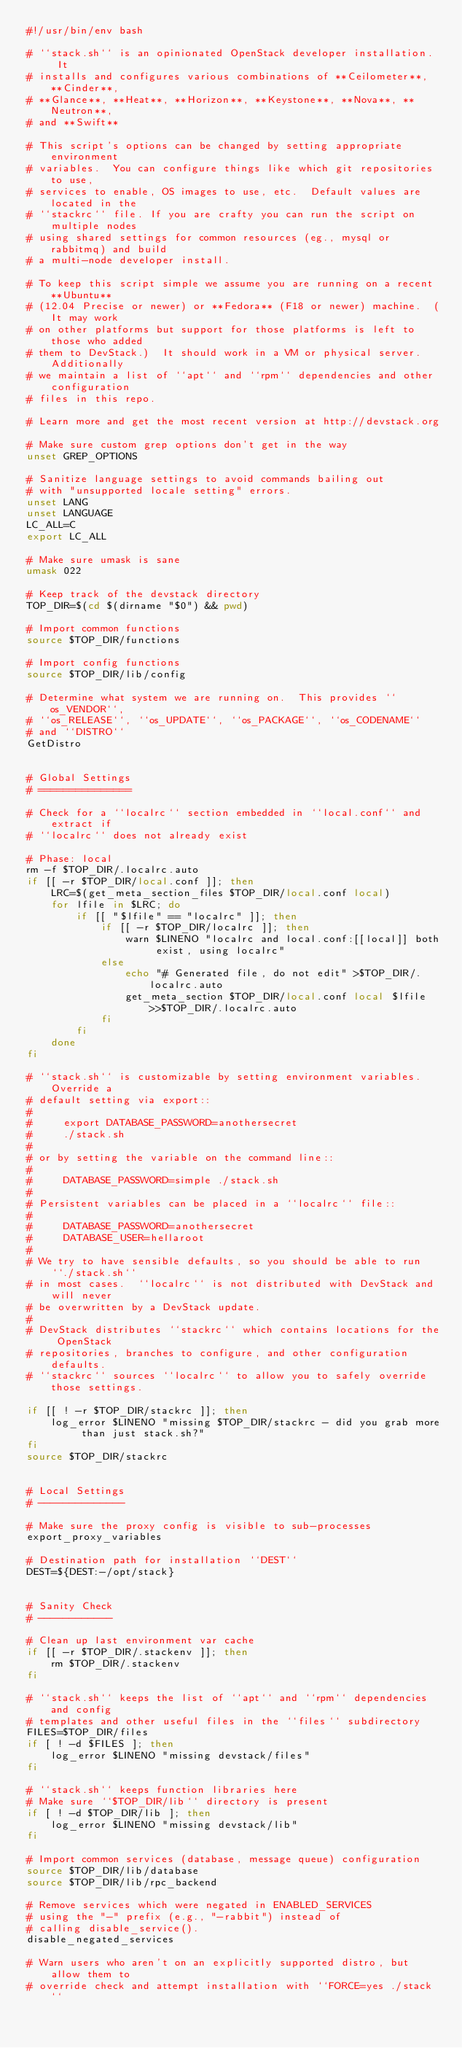<code> <loc_0><loc_0><loc_500><loc_500><_Bash_>#!/usr/bin/env bash

# ``stack.sh`` is an opinionated OpenStack developer installation.  It
# installs and configures various combinations of **Ceilometer**, **Cinder**,
# **Glance**, **Heat**, **Horizon**, **Keystone**, **Nova**, **Neutron**,
# and **Swift**

# This script's options can be changed by setting appropriate environment
# variables.  You can configure things like which git repositories to use,
# services to enable, OS images to use, etc.  Default values are located in the
# ``stackrc`` file. If you are crafty you can run the script on multiple nodes
# using shared settings for common resources (eg., mysql or rabbitmq) and build
# a multi-node developer install.

# To keep this script simple we assume you are running on a recent **Ubuntu**
# (12.04 Precise or newer) or **Fedora** (F18 or newer) machine.  (It may work
# on other platforms but support for those platforms is left to those who added
# them to DevStack.)  It should work in a VM or physical server.  Additionally
# we maintain a list of ``apt`` and ``rpm`` dependencies and other configuration
# files in this repo.

# Learn more and get the most recent version at http://devstack.org

# Make sure custom grep options don't get in the way
unset GREP_OPTIONS

# Sanitize language settings to avoid commands bailing out
# with "unsupported locale setting" errors.
unset LANG
unset LANGUAGE
LC_ALL=C
export LC_ALL

# Make sure umask is sane
umask 022

# Keep track of the devstack directory
TOP_DIR=$(cd $(dirname "$0") && pwd)

# Import common functions
source $TOP_DIR/functions

# Import config functions
source $TOP_DIR/lib/config

# Determine what system we are running on.  This provides ``os_VENDOR``,
# ``os_RELEASE``, ``os_UPDATE``, ``os_PACKAGE``, ``os_CODENAME``
# and ``DISTRO``
GetDistro


# Global Settings
# ===============

# Check for a ``localrc`` section embedded in ``local.conf`` and extract if
# ``localrc`` does not already exist

# Phase: local
rm -f $TOP_DIR/.localrc.auto
if [[ -r $TOP_DIR/local.conf ]]; then
    LRC=$(get_meta_section_files $TOP_DIR/local.conf local)
    for lfile in $LRC; do
        if [[ "$lfile" == "localrc" ]]; then
            if [[ -r $TOP_DIR/localrc ]]; then
                warn $LINENO "localrc and local.conf:[[local]] both exist, using localrc"
            else
                echo "# Generated file, do not edit" >$TOP_DIR/.localrc.auto
                get_meta_section $TOP_DIR/local.conf local $lfile >>$TOP_DIR/.localrc.auto
            fi
        fi
    done
fi

# ``stack.sh`` is customizable by setting environment variables.  Override a
# default setting via export::
#
#     export DATABASE_PASSWORD=anothersecret
#     ./stack.sh
#
# or by setting the variable on the command line::
#
#     DATABASE_PASSWORD=simple ./stack.sh
#
# Persistent variables can be placed in a ``localrc`` file::
#
#     DATABASE_PASSWORD=anothersecret
#     DATABASE_USER=hellaroot
#
# We try to have sensible defaults, so you should be able to run ``./stack.sh``
# in most cases.  ``localrc`` is not distributed with DevStack and will never
# be overwritten by a DevStack update.
#
# DevStack distributes ``stackrc`` which contains locations for the OpenStack
# repositories, branches to configure, and other configuration defaults.
# ``stackrc`` sources ``localrc`` to allow you to safely override those settings.

if [[ ! -r $TOP_DIR/stackrc ]]; then
    log_error $LINENO "missing $TOP_DIR/stackrc - did you grab more than just stack.sh?"
fi
source $TOP_DIR/stackrc


# Local Settings
# --------------

# Make sure the proxy config is visible to sub-processes
export_proxy_variables

# Destination path for installation ``DEST``
DEST=${DEST:-/opt/stack}


# Sanity Check
# ------------

# Clean up last environment var cache
if [[ -r $TOP_DIR/.stackenv ]]; then
    rm $TOP_DIR/.stackenv
fi

# ``stack.sh`` keeps the list of ``apt`` and ``rpm`` dependencies and config
# templates and other useful files in the ``files`` subdirectory
FILES=$TOP_DIR/files
if [ ! -d $FILES ]; then
    log_error $LINENO "missing devstack/files"
fi

# ``stack.sh`` keeps function libraries here
# Make sure ``$TOP_DIR/lib`` directory is present
if [ ! -d $TOP_DIR/lib ]; then
    log_error $LINENO "missing devstack/lib"
fi

# Import common services (database, message queue) configuration
source $TOP_DIR/lib/database
source $TOP_DIR/lib/rpc_backend

# Remove services which were negated in ENABLED_SERVICES
# using the "-" prefix (e.g., "-rabbit") instead of
# calling disable_service().
disable_negated_services

# Warn users who aren't on an explicitly supported distro, but allow them to
# override check and attempt installation with ``FORCE=yes ./stack``</code> 